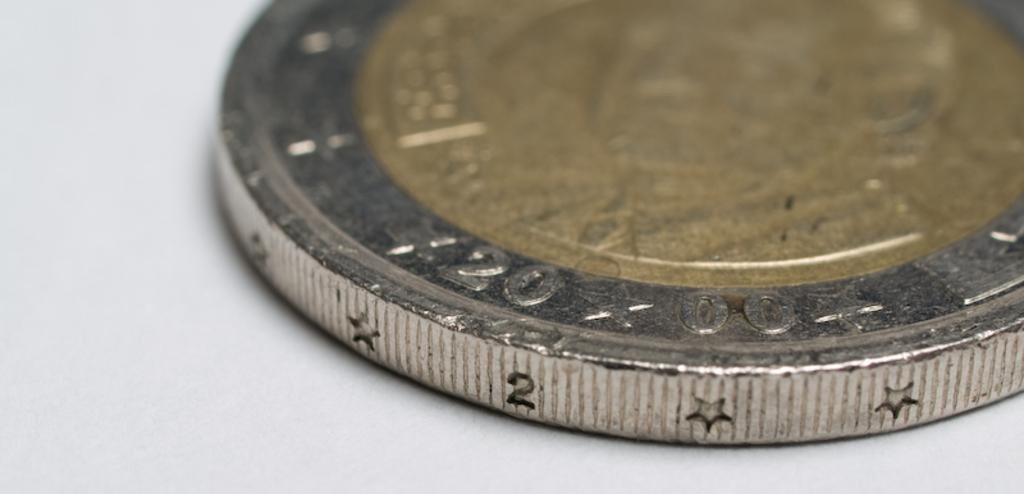<image>
Offer a succinct explanation of the picture presented. A gold coin edged with silver has repeating stars and the number 2 stamped on it. 